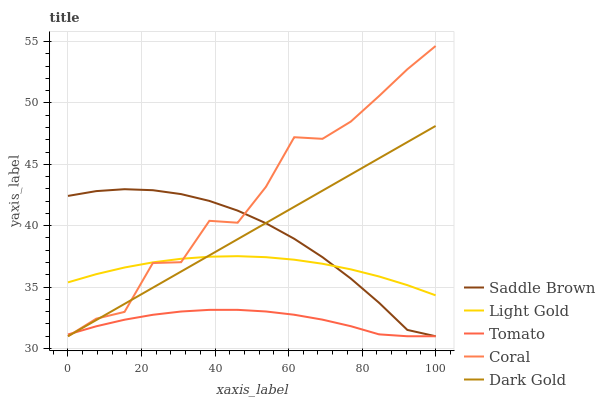Does Light Gold have the minimum area under the curve?
Answer yes or no. No. Does Light Gold have the maximum area under the curve?
Answer yes or no. No. Is Light Gold the smoothest?
Answer yes or no. No. Is Light Gold the roughest?
Answer yes or no. No. Does Light Gold have the lowest value?
Answer yes or no. No. Does Light Gold have the highest value?
Answer yes or no. No. Is Tomato less than Light Gold?
Answer yes or no. Yes. Is Light Gold greater than Tomato?
Answer yes or no. Yes. Does Tomato intersect Light Gold?
Answer yes or no. No. 